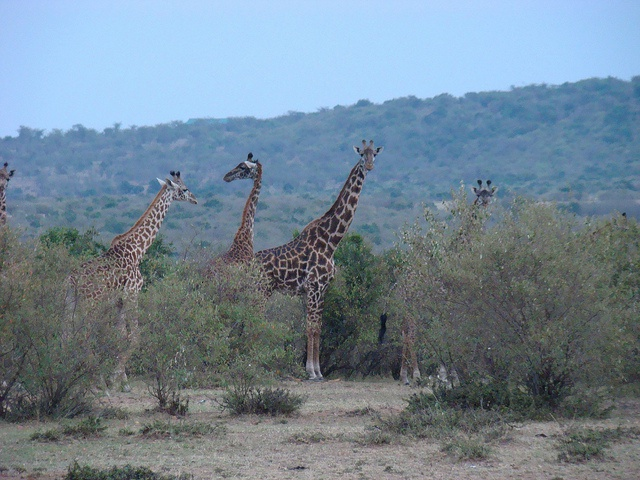Describe the objects in this image and their specific colors. I can see giraffe in lightblue, gray, and black tones, giraffe in lightblue, gray, and darkgray tones, giraffe in lightblue, gray, darkgray, and black tones, giraffe in lightblue and gray tones, and giraffe in lightblue, gray, and navy tones in this image. 